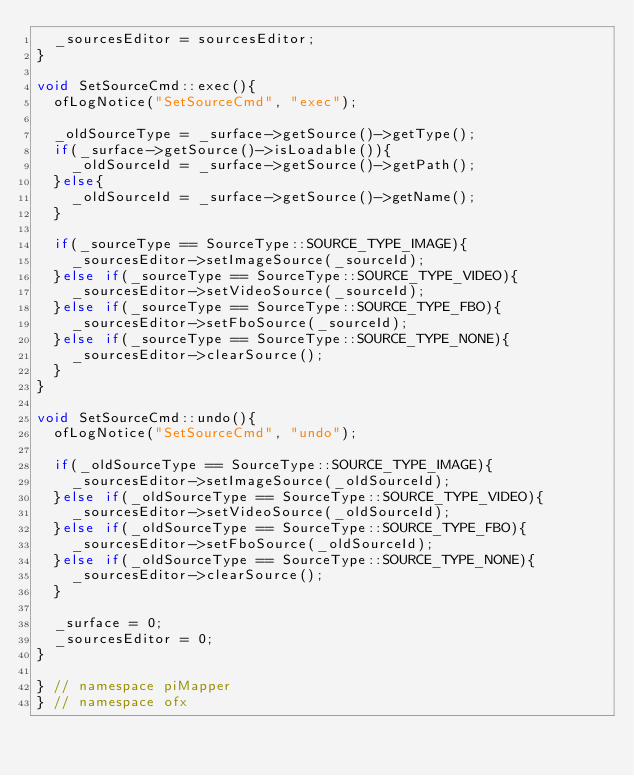Convert code to text. <code><loc_0><loc_0><loc_500><loc_500><_C++_>	_sourcesEditor = sourcesEditor;
}

void SetSourceCmd::exec(){
	ofLogNotice("SetSourceCmd", "exec");

	_oldSourceType = _surface->getSource()->getType();
	if(_surface->getSource()->isLoadable()){
		_oldSourceId = _surface->getSource()->getPath();
	}else{
		_oldSourceId = _surface->getSource()->getName();
	}

	if(_sourceType == SourceType::SOURCE_TYPE_IMAGE){
		_sourcesEditor->setImageSource(_sourceId);
	}else if(_sourceType == SourceType::SOURCE_TYPE_VIDEO){
		_sourcesEditor->setVideoSource(_sourceId);
	}else if(_sourceType == SourceType::SOURCE_TYPE_FBO){
		_sourcesEditor->setFboSource(_sourceId);
	}else if(_sourceType == SourceType::SOURCE_TYPE_NONE){
		_sourcesEditor->clearSource();
	}
}

void SetSourceCmd::undo(){
	ofLogNotice("SetSourceCmd", "undo");

	if(_oldSourceType == SourceType::SOURCE_TYPE_IMAGE){
		_sourcesEditor->setImageSource(_oldSourceId);
	}else if(_oldSourceType == SourceType::SOURCE_TYPE_VIDEO){
		_sourcesEditor->setVideoSource(_oldSourceId);
	}else if(_oldSourceType == SourceType::SOURCE_TYPE_FBO){
		_sourcesEditor->setFboSource(_oldSourceId);
	}else if(_oldSourceType == SourceType::SOURCE_TYPE_NONE){
		_sourcesEditor->clearSource();
	}

	_surface = 0;
	_sourcesEditor = 0;
}

} // namespace piMapper
} // namespace ofx

</code> 